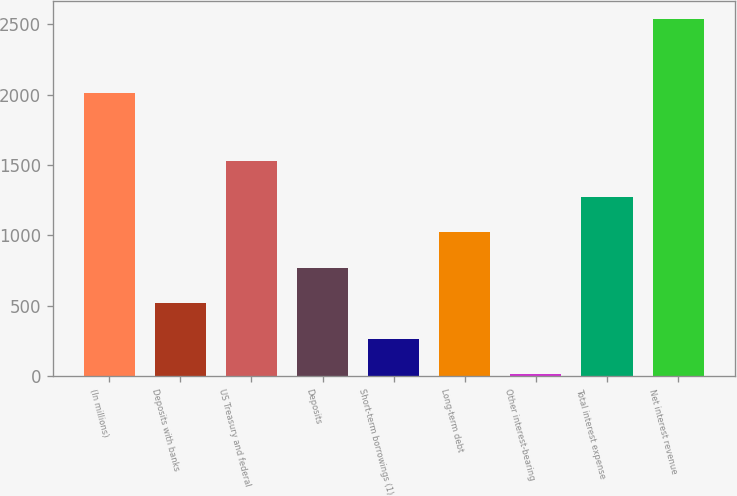Convert chart to OTSL. <chart><loc_0><loc_0><loc_500><loc_500><bar_chart><fcel>(In millions)<fcel>Deposits with banks<fcel>US Treasury and federal<fcel>Deposits<fcel>Short-term borrowings (1)<fcel>Long-term debt<fcel>Other interest-bearing<fcel>Total interest expense<fcel>Net interest revenue<nl><fcel>2012<fcel>519.6<fcel>1528.8<fcel>771.9<fcel>267.3<fcel>1024.2<fcel>15<fcel>1276.5<fcel>2538<nl></chart> 